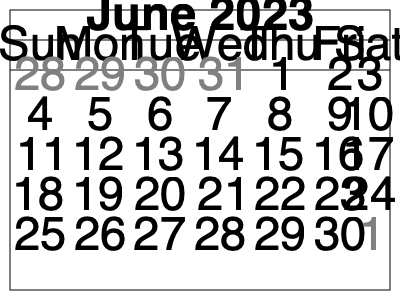Using the June 2023 calendar provided, create a weekly visitation schedule that ensures each parent has equal time with the child, including alternating weekends. Assume Parent A has the child for the first weekend (June 2-4). How many full weeks are there in this month for implementing a consistent schedule? To create a fair visitation schedule and determine the number of full weeks available, let's follow these steps:

1. Identify the start and end of the month:
   - June 2023 starts on a Thursday (June 1) and ends on a Friday (June 30).

2. Identify full weeks:
   - A full week runs from Sunday to Saturday.
   - The first full week starts on Sunday, June 4.
   - The last full week ends on Saturday, June 24.

3. Count the number of full weeks:
   - Week 1: June 4-10
   - Week 2: June 11-17
   - Week 3: June 18-24

4. Proposed schedule for full weeks:
   - Parent A: June 4-10 (Week 1)
   - Parent B: June 11-17 (Week 2)
   - Parent A: June 18-24 (Week 3)

5. Handle partial weeks:
   - First partial week (June 1-3): Parent A (as given in the question)
   - Last partial week (June 25-30): Parent B (to maintain alternation)

This schedule ensures each parent has equal time with the child during the full weeks and alternates weekends. The partial weeks at the beginning and end of the month can be used to balance any discrepancies and maintain the alternating weekend pattern.
Answer: 3 full weeks 